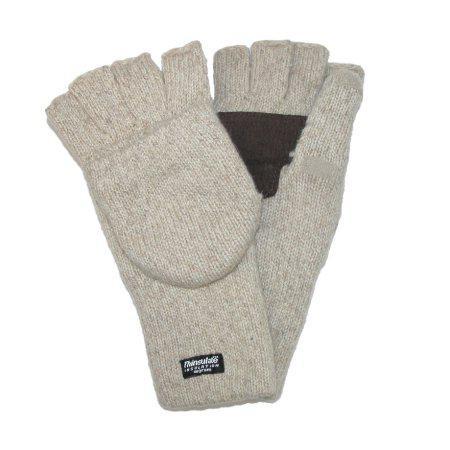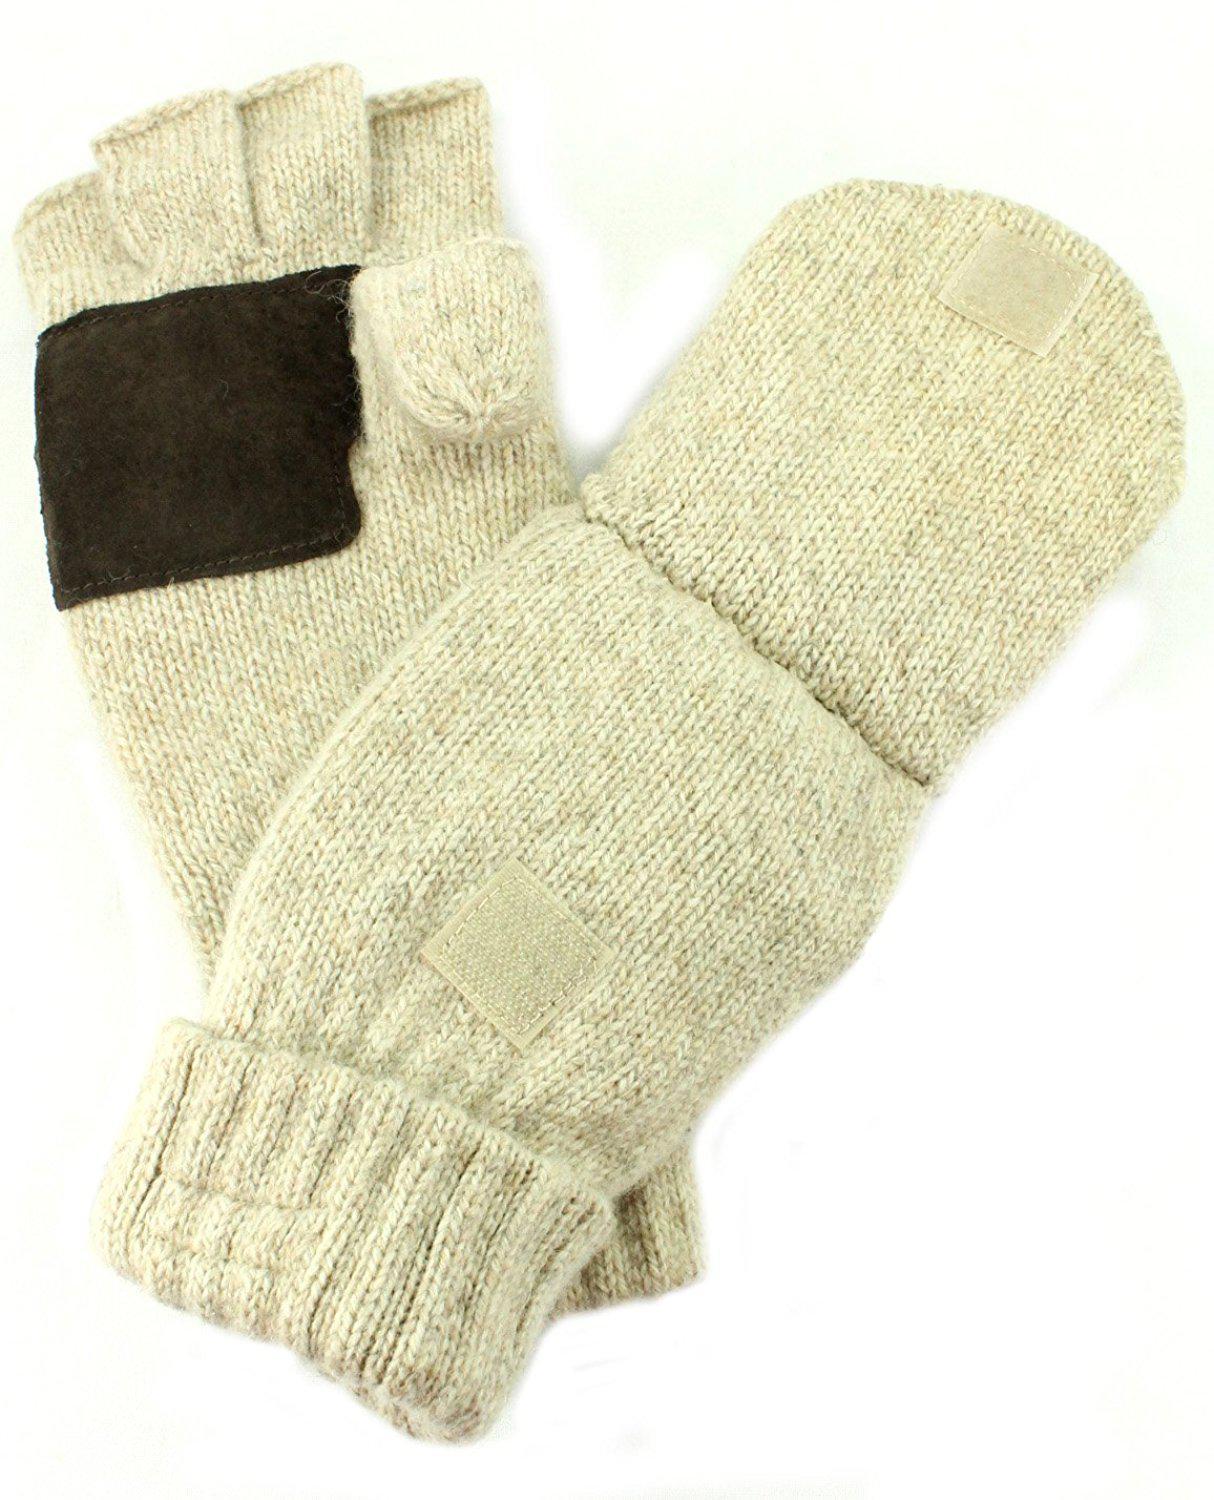The first image is the image on the left, the second image is the image on the right. Assess this claim about the two images: "a mannequin's hand is wearing a glove.". Correct or not? Answer yes or no. No. The first image is the image on the left, the second image is the image on the right. Analyze the images presented: Is the assertion "A fingerless glove in a taupe color with ribbed detailing in the wrist section is modeled in one image by a black hand mannequin." valid? Answer yes or no. No. 